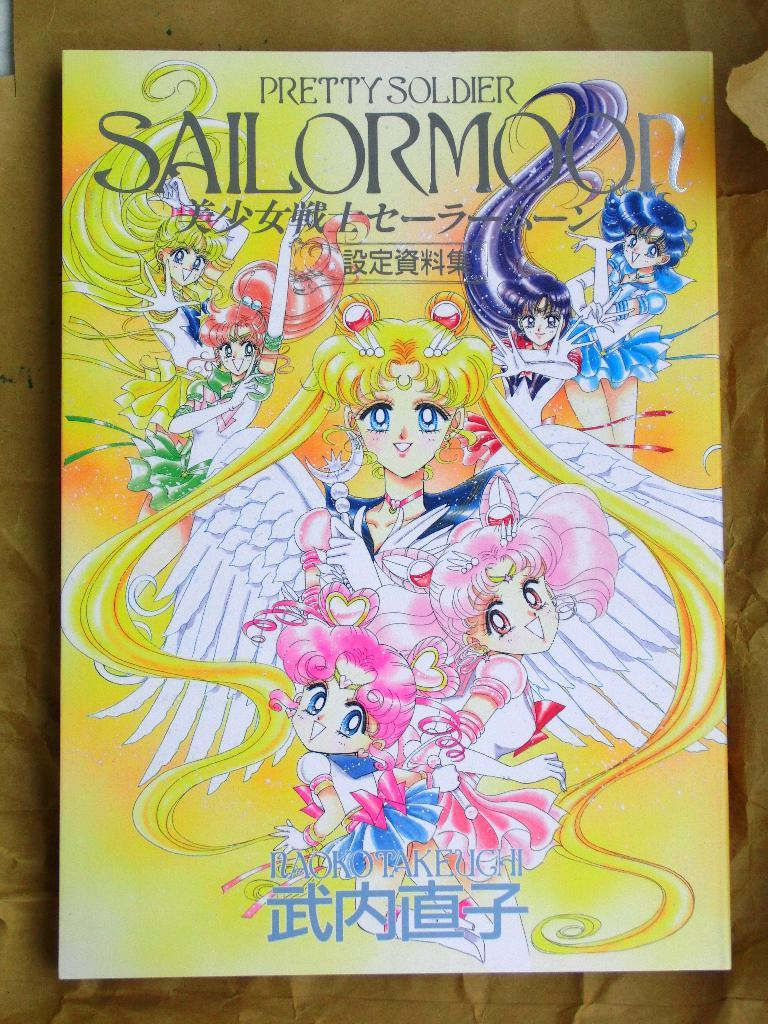<image>
Give a short and clear explanation of the subsequent image. Book cover showing anime characters and the words"Pretty soldier" on top. 